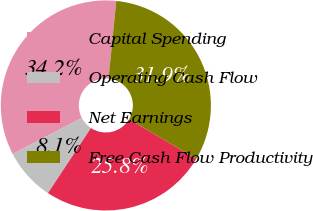Convert chart. <chart><loc_0><loc_0><loc_500><loc_500><pie_chart><fcel>Capital Spending<fcel>Operating Cash Flow<fcel>Net Earnings<fcel>Free Cash Flow Productivity<nl><fcel>34.23%<fcel>8.07%<fcel>25.81%<fcel>31.89%<nl></chart> 